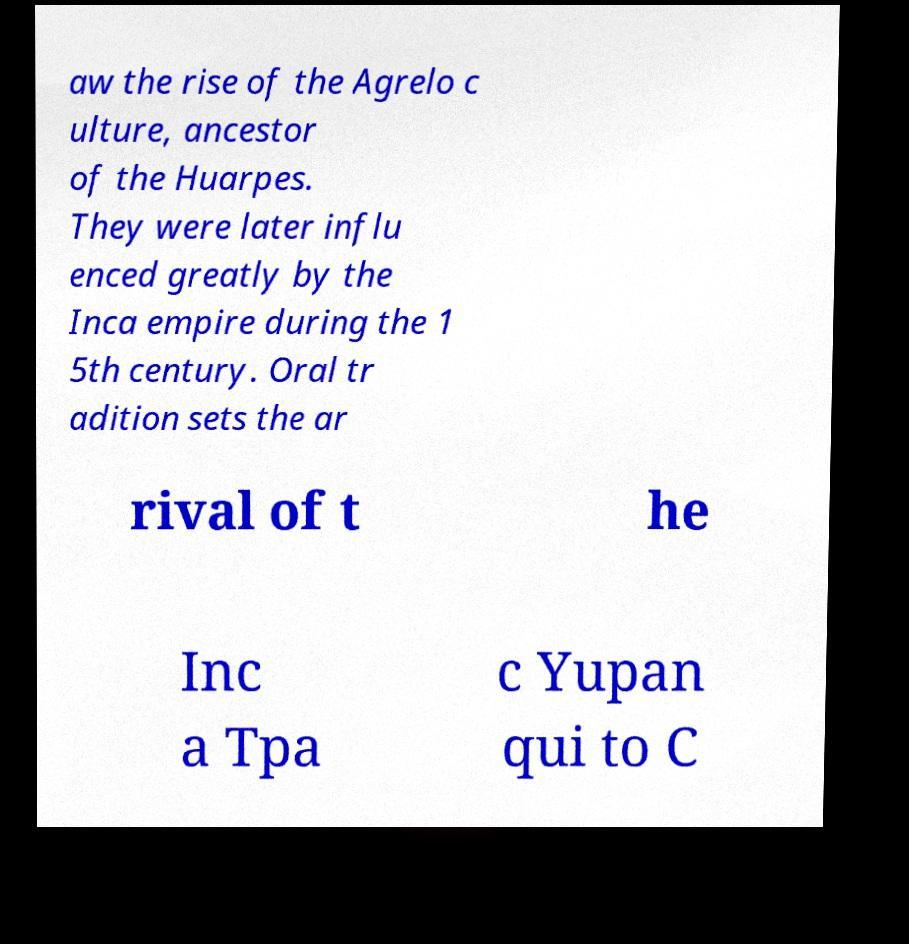There's text embedded in this image that I need extracted. Can you transcribe it verbatim? aw the rise of the Agrelo c ulture, ancestor of the Huarpes. They were later influ enced greatly by the Inca empire during the 1 5th century. Oral tr adition sets the ar rival of t he Inc a Tpa c Yupan qui to C 